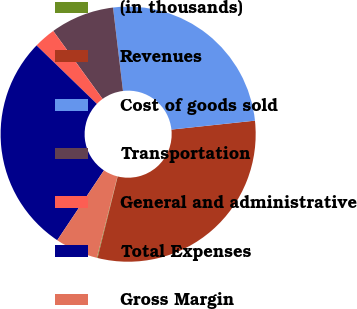<chart> <loc_0><loc_0><loc_500><loc_500><pie_chart><fcel>(in thousands)<fcel>Revenues<fcel>Cost of goods sold<fcel>Transportation<fcel>General and administrative<fcel>Total Expenses<fcel>Gross Margin<nl><fcel>0.09%<fcel>30.55%<fcel>25.2%<fcel>8.1%<fcel>2.76%<fcel>27.87%<fcel>5.43%<nl></chart> 